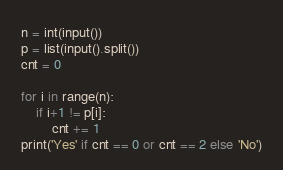Convert code to text. <code><loc_0><loc_0><loc_500><loc_500><_Python_>n = int(input())
p = list(input().split())
cnt = 0

for i in range(n):
    if i+1 != p[i]:
        cnt += 1
print('Yes' if cnt == 0 or cnt == 2 else 'No')
</code> 